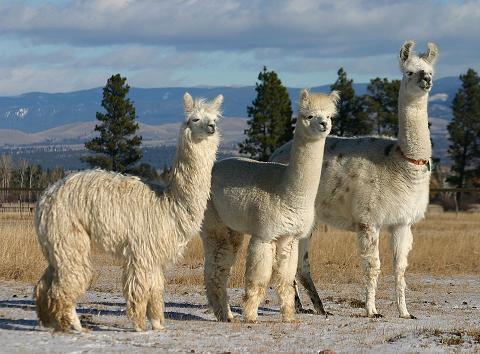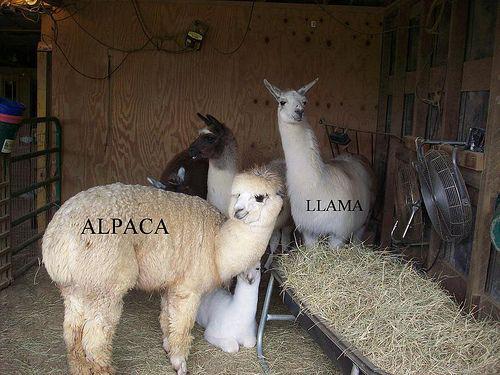The first image is the image on the left, the second image is the image on the right. Evaluate the accuracy of this statement regarding the images: "There are two llamas in one of the images.". Is it true? Answer yes or no. No. The first image is the image on the left, the second image is the image on the right. Considering the images on both sides, is "The left image contains at least three llamas standing in a row and gazing in the same direction." valid? Answer yes or no. Yes. 